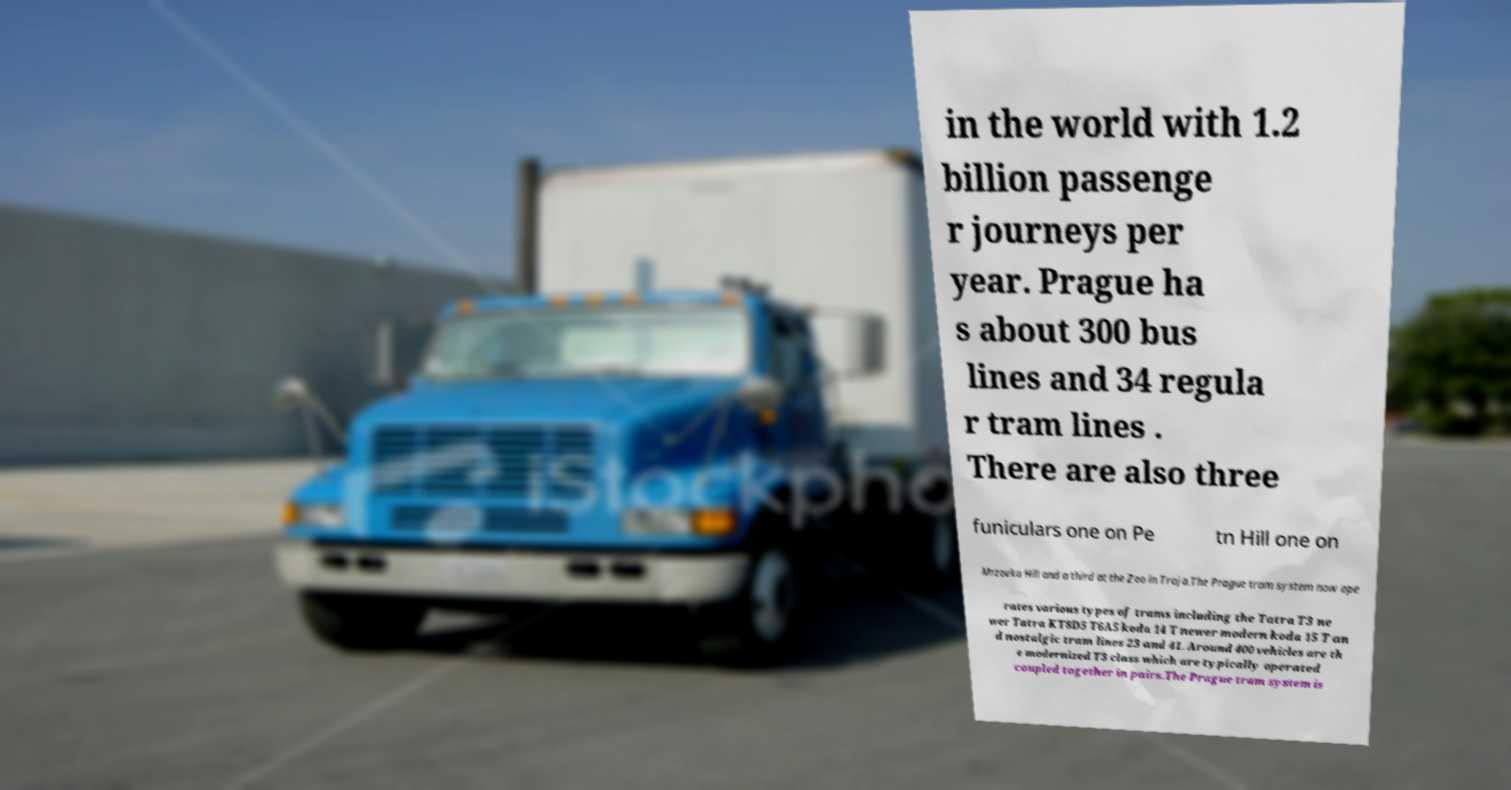Please read and relay the text visible in this image. What does it say? in the world with 1.2 billion passenge r journeys per year. Prague ha s about 300 bus lines and 34 regula r tram lines . There are also three funiculars one on Pe tn Hill one on Mrzovka Hill and a third at the Zoo in Troja.The Prague tram system now ope rates various types of trams including the Tatra T3 ne wer Tatra KT8D5 T6A5 koda 14 T newer modern koda 15 T an d nostalgic tram lines 23 and 41. Around 400 vehicles are th e modernized T3 class which are typically operated coupled together in pairs.The Prague tram system is 